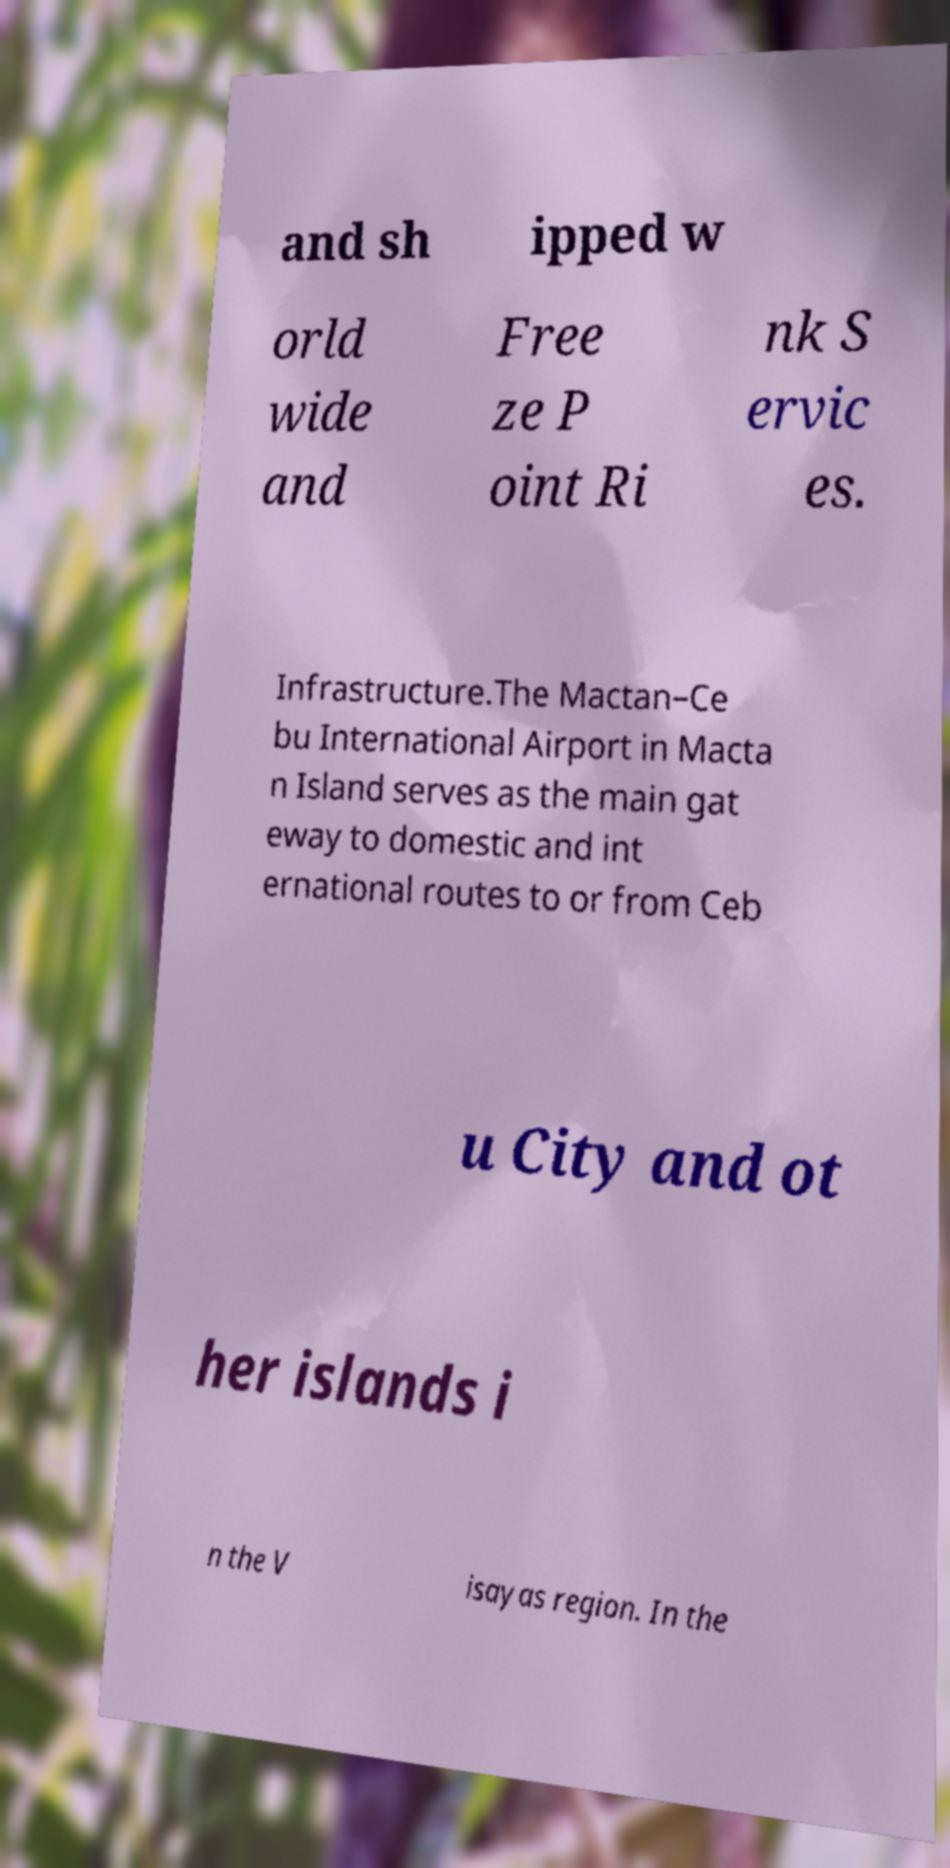What messages or text are displayed in this image? I need them in a readable, typed format. and sh ipped w orld wide and Free ze P oint Ri nk S ervic es. Infrastructure.The Mactan–Ce bu International Airport in Macta n Island serves as the main gat eway to domestic and int ernational routes to or from Ceb u City and ot her islands i n the V isayas region. In the 